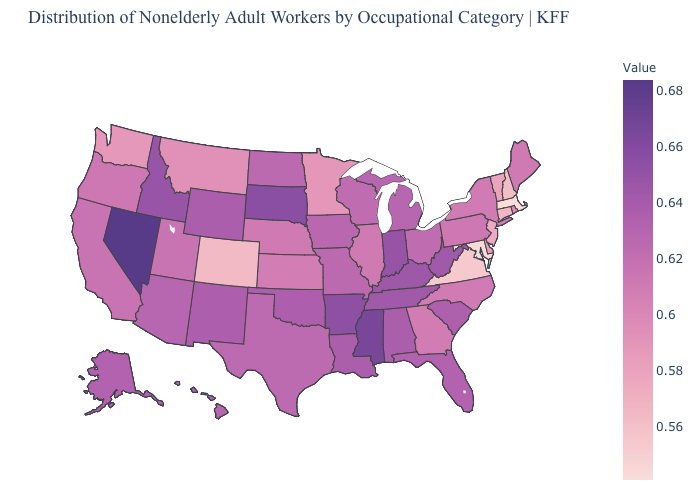Which states have the lowest value in the USA?
Concise answer only. Massachusetts. Does Connecticut have a lower value than Maryland?
Write a very short answer. No. Is the legend a continuous bar?
Concise answer only. Yes. Does Maryland have the highest value in the South?
Quick response, please. No. Among the states that border Oklahoma , does Missouri have the lowest value?
Short answer required. No. Is the legend a continuous bar?
Keep it brief. Yes. Among the states that border Nevada , which have the highest value?
Be succinct. Idaho. Which states hav the highest value in the South?
Keep it brief. Mississippi. Does the map have missing data?
Answer briefly. No. 